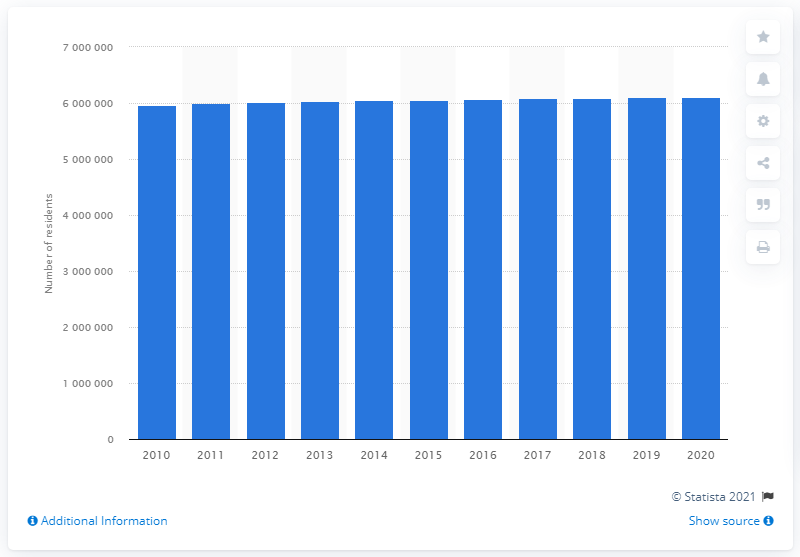List a handful of essential elements in this visual. In 2020, the population of the Philadelphia-Camden-Wilmington metropolitan area was estimated to be 6,049,852. In 2010, the population of the Philadelphia-Camden-Wilmington metropolitan area was 597,1202. 